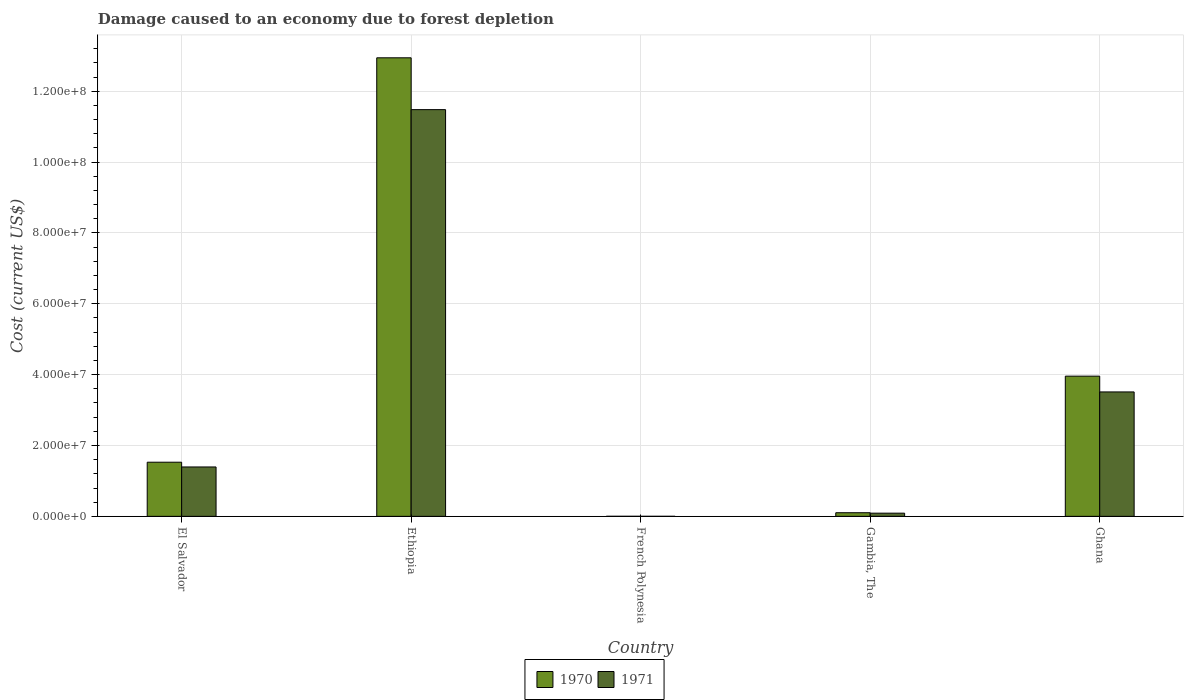How many bars are there on the 1st tick from the left?
Keep it short and to the point. 2. How many bars are there on the 3rd tick from the right?
Give a very brief answer. 2. What is the label of the 3rd group of bars from the left?
Keep it short and to the point. French Polynesia. In how many cases, is the number of bars for a given country not equal to the number of legend labels?
Give a very brief answer. 0. What is the cost of damage caused due to forest depletion in 1970 in Ethiopia?
Your answer should be very brief. 1.29e+08. Across all countries, what is the maximum cost of damage caused due to forest depletion in 1971?
Provide a short and direct response. 1.15e+08. Across all countries, what is the minimum cost of damage caused due to forest depletion in 1971?
Your answer should be very brief. 9061.15. In which country was the cost of damage caused due to forest depletion in 1970 maximum?
Provide a short and direct response. Ethiopia. In which country was the cost of damage caused due to forest depletion in 1970 minimum?
Offer a terse response. French Polynesia. What is the total cost of damage caused due to forest depletion in 1970 in the graph?
Give a very brief answer. 1.85e+08. What is the difference between the cost of damage caused due to forest depletion in 1970 in Ethiopia and that in French Polynesia?
Provide a succinct answer. 1.29e+08. What is the difference between the cost of damage caused due to forest depletion in 1970 in El Salvador and the cost of damage caused due to forest depletion in 1971 in Ethiopia?
Offer a very short reply. -9.95e+07. What is the average cost of damage caused due to forest depletion in 1971 per country?
Ensure brevity in your answer.  3.30e+07. What is the difference between the cost of damage caused due to forest depletion of/in 1971 and cost of damage caused due to forest depletion of/in 1970 in Ghana?
Your answer should be very brief. -4.46e+06. What is the ratio of the cost of damage caused due to forest depletion in 1971 in El Salvador to that in Ghana?
Ensure brevity in your answer.  0.4. Is the difference between the cost of damage caused due to forest depletion in 1971 in Ethiopia and Ghana greater than the difference between the cost of damage caused due to forest depletion in 1970 in Ethiopia and Ghana?
Keep it short and to the point. No. What is the difference between the highest and the second highest cost of damage caused due to forest depletion in 1970?
Keep it short and to the point. 2.43e+07. What is the difference between the highest and the lowest cost of damage caused due to forest depletion in 1970?
Your response must be concise. 1.29e+08. What does the 1st bar from the left in Ethiopia represents?
Your answer should be compact. 1970. How many bars are there?
Give a very brief answer. 10. Are all the bars in the graph horizontal?
Provide a succinct answer. No. What is the difference between two consecutive major ticks on the Y-axis?
Offer a very short reply. 2.00e+07. Are the values on the major ticks of Y-axis written in scientific E-notation?
Offer a very short reply. Yes. Does the graph contain grids?
Ensure brevity in your answer.  Yes. How many legend labels are there?
Your answer should be compact. 2. What is the title of the graph?
Give a very brief answer. Damage caused to an economy due to forest depletion. Does "1984" appear as one of the legend labels in the graph?
Give a very brief answer. No. What is the label or title of the Y-axis?
Offer a very short reply. Cost (current US$). What is the Cost (current US$) of 1970 in El Salvador?
Offer a terse response. 1.53e+07. What is the Cost (current US$) of 1971 in El Salvador?
Ensure brevity in your answer.  1.39e+07. What is the Cost (current US$) in 1970 in Ethiopia?
Provide a short and direct response. 1.29e+08. What is the Cost (current US$) in 1971 in Ethiopia?
Give a very brief answer. 1.15e+08. What is the Cost (current US$) in 1970 in French Polynesia?
Make the answer very short. 1.18e+04. What is the Cost (current US$) of 1971 in French Polynesia?
Your answer should be compact. 9061.15. What is the Cost (current US$) in 1970 in Gambia, The?
Keep it short and to the point. 1.02e+06. What is the Cost (current US$) in 1971 in Gambia, The?
Keep it short and to the point. 8.98e+05. What is the Cost (current US$) of 1970 in Ghana?
Offer a terse response. 3.96e+07. What is the Cost (current US$) in 1971 in Ghana?
Your answer should be very brief. 3.51e+07. Across all countries, what is the maximum Cost (current US$) of 1970?
Provide a short and direct response. 1.29e+08. Across all countries, what is the maximum Cost (current US$) in 1971?
Your answer should be very brief. 1.15e+08. Across all countries, what is the minimum Cost (current US$) of 1970?
Your answer should be very brief. 1.18e+04. Across all countries, what is the minimum Cost (current US$) in 1971?
Make the answer very short. 9061.15. What is the total Cost (current US$) of 1970 in the graph?
Give a very brief answer. 1.85e+08. What is the total Cost (current US$) of 1971 in the graph?
Your response must be concise. 1.65e+08. What is the difference between the Cost (current US$) in 1970 in El Salvador and that in Ethiopia?
Your response must be concise. -1.14e+08. What is the difference between the Cost (current US$) of 1971 in El Salvador and that in Ethiopia?
Provide a short and direct response. -1.01e+08. What is the difference between the Cost (current US$) in 1970 in El Salvador and that in French Polynesia?
Your answer should be very brief. 1.53e+07. What is the difference between the Cost (current US$) in 1971 in El Salvador and that in French Polynesia?
Your answer should be very brief. 1.39e+07. What is the difference between the Cost (current US$) in 1970 in El Salvador and that in Gambia, The?
Ensure brevity in your answer.  1.43e+07. What is the difference between the Cost (current US$) in 1971 in El Salvador and that in Gambia, The?
Your answer should be compact. 1.30e+07. What is the difference between the Cost (current US$) of 1970 in El Salvador and that in Ghana?
Offer a terse response. -2.43e+07. What is the difference between the Cost (current US$) of 1971 in El Salvador and that in Ghana?
Offer a very short reply. -2.12e+07. What is the difference between the Cost (current US$) in 1970 in Ethiopia and that in French Polynesia?
Your answer should be very brief. 1.29e+08. What is the difference between the Cost (current US$) in 1971 in Ethiopia and that in French Polynesia?
Offer a terse response. 1.15e+08. What is the difference between the Cost (current US$) of 1970 in Ethiopia and that in Gambia, The?
Ensure brevity in your answer.  1.28e+08. What is the difference between the Cost (current US$) of 1971 in Ethiopia and that in Gambia, The?
Offer a terse response. 1.14e+08. What is the difference between the Cost (current US$) of 1970 in Ethiopia and that in Ghana?
Your response must be concise. 8.99e+07. What is the difference between the Cost (current US$) of 1971 in Ethiopia and that in Ghana?
Your answer should be very brief. 7.97e+07. What is the difference between the Cost (current US$) of 1970 in French Polynesia and that in Gambia, The?
Your answer should be very brief. -1.01e+06. What is the difference between the Cost (current US$) of 1971 in French Polynesia and that in Gambia, The?
Offer a very short reply. -8.89e+05. What is the difference between the Cost (current US$) of 1970 in French Polynesia and that in Ghana?
Your answer should be compact. -3.96e+07. What is the difference between the Cost (current US$) of 1971 in French Polynesia and that in Ghana?
Offer a very short reply. -3.51e+07. What is the difference between the Cost (current US$) of 1970 in Gambia, The and that in Ghana?
Offer a terse response. -3.86e+07. What is the difference between the Cost (current US$) in 1971 in Gambia, The and that in Ghana?
Your response must be concise. -3.42e+07. What is the difference between the Cost (current US$) of 1970 in El Salvador and the Cost (current US$) of 1971 in Ethiopia?
Your answer should be compact. -9.95e+07. What is the difference between the Cost (current US$) in 1970 in El Salvador and the Cost (current US$) in 1971 in French Polynesia?
Your answer should be very brief. 1.53e+07. What is the difference between the Cost (current US$) of 1970 in El Salvador and the Cost (current US$) of 1971 in Gambia, The?
Your response must be concise. 1.44e+07. What is the difference between the Cost (current US$) in 1970 in El Salvador and the Cost (current US$) in 1971 in Ghana?
Offer a terse response. -1.98e+07. What is the difference between the Cost (current US$) in 1970 in Ethiopia and the Cost (current US$) in 1971 in French Polynesia?
Your answer should be compact. 1.29e+08. What is the difference between the Cost (current US$) of 1970 in Ethiopia and the Cost (current US$) of 1971 in Gambia, The?
Provide a short and direct response. 1.29e+08. What is the difference between the Cost (current US$) of 1970 in Ethiopia and the Cost (current US$) of 1971 in Ghana?
Your answer should be very brief. 9.43e+07. What is the difference between the Cost (current US$) of 1970 in French Polynesia and the Cost (current US$) of 1971 in Gambia, The?
Provide a short and direct response. -8.86e+05. What is the difference between the Cost (current US$) of 1970 in French Polynesia and the Cost (current US$) of 1971 in Ghana?
Provide a short and direct response. -3.51e+07. What is the difference between the Cost (current US$) in 1970 in Gambia, The and the Cost (current US$) in 1971 in Ghana?
Make the answer very short. -3.41e+07. What is the average Cost (current US$) in 1970 per country?
Keep it short and to the point. 3.71e+07. What is the average Cost (current US$) of 1971 per country?
Make the answer very short. 3.30e+07. What is the difference between the Cost (current US$) of 1970 and Cost (current US$) of 1971 in El Salvador?
Provide a succinct answer. 1.34e+06. What is the difference between the Cost (current US$) in 1970 and Cost (current US$) in 1971 in Ethiopia?
Provide a succinct answer. 1.46e+07. What is the difference between the Cost (current US$) of 1970 and Cost (current US$) of 1971 in French Polynesia?
Ensure brevity in your answer.  2690.05. What is the difference between the Cost (current US$) of 1970 and Cost (current US$) of 1971 in Gambia, The?
Your answer should be compact. 1.21e+05. What is the difference between the Cost (current US$) of 1970 and Cost (current US$) of 1971 in Ghana?
Offer a very short reply. 4.46e+06. What is the ratio of the Cost (current US$) in 1970 in El Salvador to that in Ethiopia?
Your answer should be very brief. 0.12. What is the ratio of the Cost (current US$) in 1971 in El Salvador to that in Ethiopia?
Make the answer very short. 0.12. What is the ratio of the Cost (current US$) in 1970 in El Salvador to that in French Polynesia?
Your response must be concise. 1300.42. What is the ratio of the Cost (current US$) in 1971 in El Salvador to that in French Polynesia?
Provide a succinct answer. 1538.5. What is the ratio of the Cost (current US$) of 1970 in El Salvador to that in Gambia, The?
Your answer should be very brief. 14.99. What is the ratio of the Cost (current US$) in 1971 in El Salvador to that in Gambia, The?
Offer a very short reply. 15.52. What is the ratio of the Cost (current US$) in 1970 in El Salvador to that in Ghana?
Offer a terse response. 0.39. What is the ratio of the Cost (current US$) in 1971 in El Salvador to that in Ghana?
Offer a terse response. 0.4. What is the ratio of the Cost (current US$) of 1970 in Ethiopia to that in French Polynesia?
Make the answer very short. 1.10e+04. What is the ratio of the Cost (current US$) of 1971 in Ethiopia to that in French Polynesia?
Offer a very short reply. 1.27e+04. What is the ratio of the Cost (current US$) in 1970 in Ethiopia to that in Gambia, The?
Your response must be concise. 126.96. What is the ratio of the Cost (current US$) in 1971 in Ethiopia to that in Gambia, The?
Provide a succinct answer. 127.81. What is the ratio of the Cost (current US$) of 1970 in Ethiopia to that in Ghana?
Your answer should be very brief. 3.27. What is the ratio of the Cost (current US$) of 1971 in Ethiopia to that in Ghana?
Your answer should be compact. 3.27. What is the ratio of the Cost (current US$) of 1970 in French Polynesia to that in Gambia, The?
Your answer should be very brief. 0.01. What is the ratio of the Cost (current US$) of 1971 in French Polynesia to that in Gambia, The?
Give a very brief answer. 0.01. What is the ratio of the Cost (current US$) of 1970 in Gambia, The to that in Ghana?
Your answer should be compact. 0.03. What is the ratio of the Cost (current US$) in 1971 in Gambia, The to that in Ghana?
Offer a very short reply. 0.03. What is the difference between the highest and the second highest Cost (current US$) in 1970?
Keep it short and to the point. 8.99e+07. What is the difference between the highest and the second highest Cost (current US$) of 1971?
Offer a very short reply. 7.97e+07. What is the difference between the highest and the lowest Cost (current US$) in 1970?
Give a very brief answer. 1.29e+08. What is the difference between the highest and the lowest Cost (current US$) in 1971?
Your answer should be compact. 1.15e+08. 